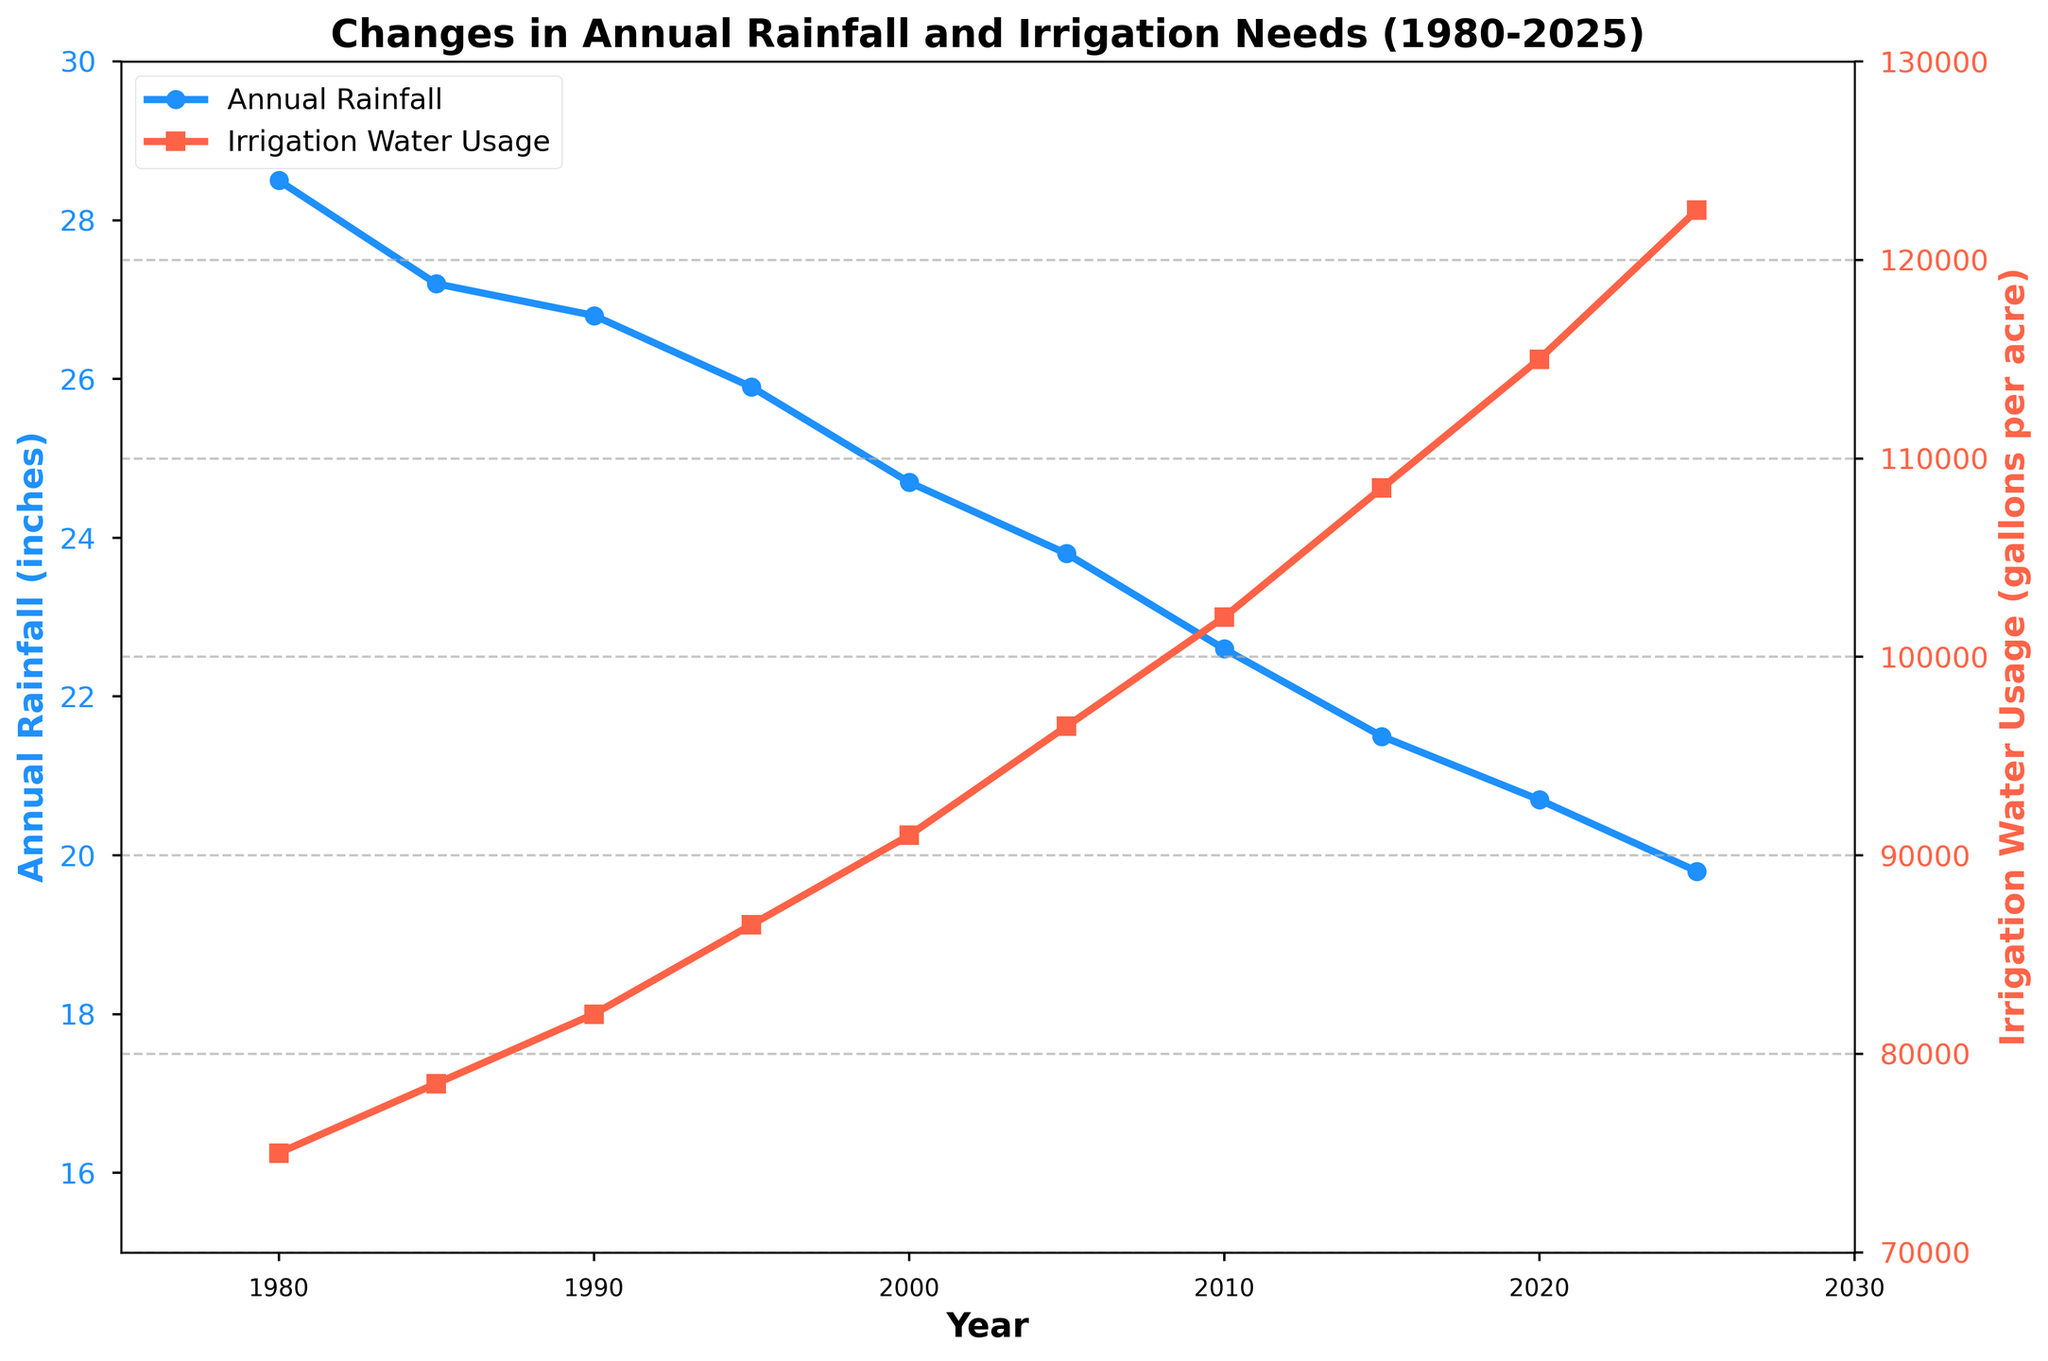What was the rainfall in 1985 and 2025? By looking at the chart, locate the values for Annual Rainfall for the years 1985 and 2025. For 1985, it is 27.2 inches, and for 2025, it is 19.8 inches.
Answer: 27.2 inches (1985), 19.8 inches (2025) How has irrigation water usage changed between 2010 and 2025? Find the values for Irrigation Water Usage in 2010 and 2025. Subtract the 2010 value (102,000 gallons per acre) from the 2025 value (122,500 gallons per acre). The difference is the increase in usage. 122,500 - 102,000 = 20,500 gallons per acre.
Answer: Increased by 20,500 gallons per acre Between which two consecutive years did rainfall decrease the most? Compare the decreases in Annual Rainfall between each pair of consecutive years and identify the largest drop. The largest decrease occurs between 2015 and 2020, with a reduction from 21.5 inches to 20.7 inches (21.5 - 20.7 = 0.8 inches).
Answer: Between 2015 and 2020 Which year marked the highest irrigation water usage? Look at the Irrigation Water Usage line in the chart and find the peak value. The year 2025 has the highest usage at 122,500 gallons per acre.
Answer: 2025 What are the overall trends in rainfall and irrigation water usage from 1980 to 2025? Observe the trendlines for Annual Rainfall and Irrigation Water Usage. Rainfall is consistently decreasing from 28.5 inches in 1980 to 19.8 inches in 2025, while Irrigation Water Usage is consistently increasing from 75,000 gallons per acre in 1980 to 122,500 gallons per acre in 2025.
Answer: Rainfall is decreasing, Irrigation water usage is increasing 